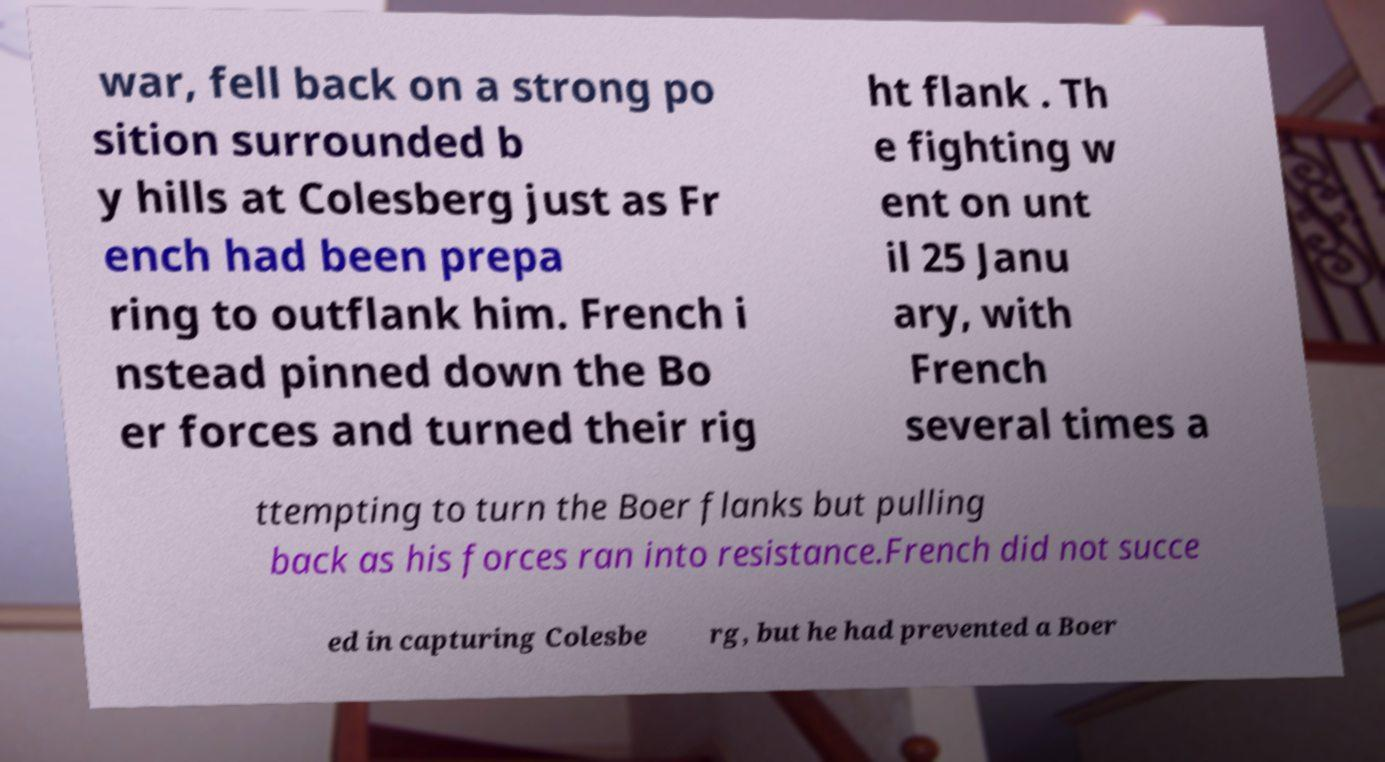I need the written content from this picture converted into text. Can you do that? war, fell back on a strong po sition surrounded b y hills at Colesberg just as Fr ench had been prepa ring to outflank him. French i nstead pinned down the Bo er forces and turned their rig ht flank . Th e fighting w ent on unt il 25 Janu ary, with French several times a ttempting to turn the Boer flanks but pulling back as his forces ran into resistance.French did not succe ed in capturing Colesbe rg, but he had prevented a Boer 